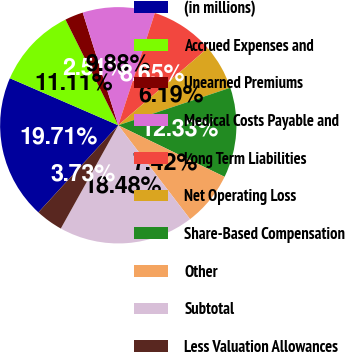Convert chart to OTSL. <chart><loc_0><loc_0><loc_500><loc_500><pie_chart><fcel>(in millions)<fcel>Accrued Expenses and<fcel>Unearned Premiums<fcel>Medical Costs Payable and<fcel>Long Term Liabilities<fcel>Net Operating Loss<fcel>Share-Based Compensation<fcel>Other<fcel>Subtotal<fcel>Less Valuation Allowances<nl><fcel>19.71%<fcel>11.11%<fcel>2.51%<fcel>9.88%<fcel>8.65%<fcel>6.19%<fcel>12.33%<fcel>7.42%<fcel>18.48%<fcel>3.73%<nl></chart> 